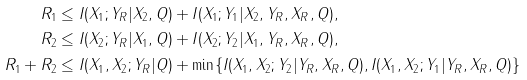Convert formula to latex. <formula><loc_0><loc_0><loc_500><loc_500>R _ { 1 } & \leq I ( X _ { 1 } ; Y _ { R } | X _ { 2 } , Q ) + I ( X _ { 1 } ; Y _ { 1 } | X _ { 2 } , Y _ { R } , X _ { R } , Q ) , \\ R _ { 2 } & \leq I ( X _ { 2 } ; Y _ { R } | X _ { 1 } , Q ) + I ( X _ { 2 } ; Y _ { 2 } | X _ { 1 } , Y _ { R } , X _ { R } , Q ) , \\ R _ { 1 } + R _ { 2 } & \leq I ( X _ { 1 } , X _ { 2 } ; Y _ { R } | Q ) + \min \{ I ( X _ { 1 } , X _ { 2 } ; Y _ { 2 } | Y _ { R } , X _ { R } , Q ) , I ( X _ { 1 } , X _ { 2 } ; Y _ { 1 } | Y _ { R } , X _ { R } , Q ) \}</formula> 